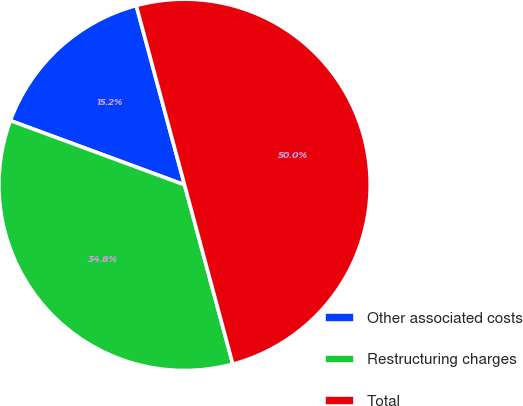Convert chart to OTSL. <chart><loc_0><loc_0><loc_500><loc_500><pie_chart><fcel>Other associated costs<fcel>Restructuring charges<fcel>Total<nl><fcel>15.19%<fcel>34.81%<fcel>50.0%<nl></chart> 